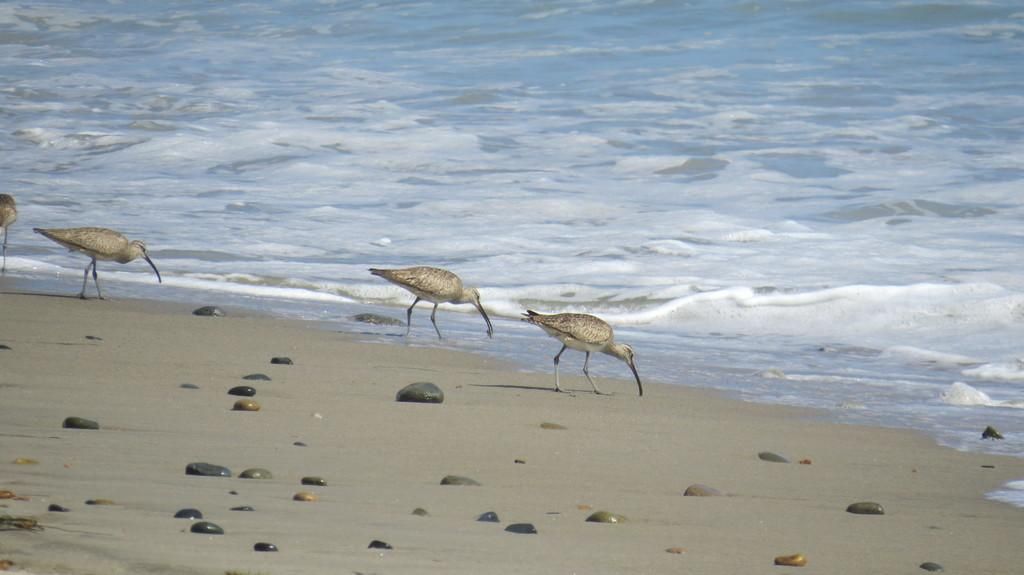What type of animals can be seen in the image? There are birds in the image. Where are the birds located? The birds are standing on land. What can be found on the land in the image? There are rocks on the land. What is visible in the background of the image? The background of the image includes water. What is a characteristic of the water in the image? The water has tides. What type of cheese can be seen in the image? There is no cheese present in the image. How does the loss of butter affect the birds in the image? There is no mention of butter or any loss in the image, so it cannot be determined how it would affect the birds. 